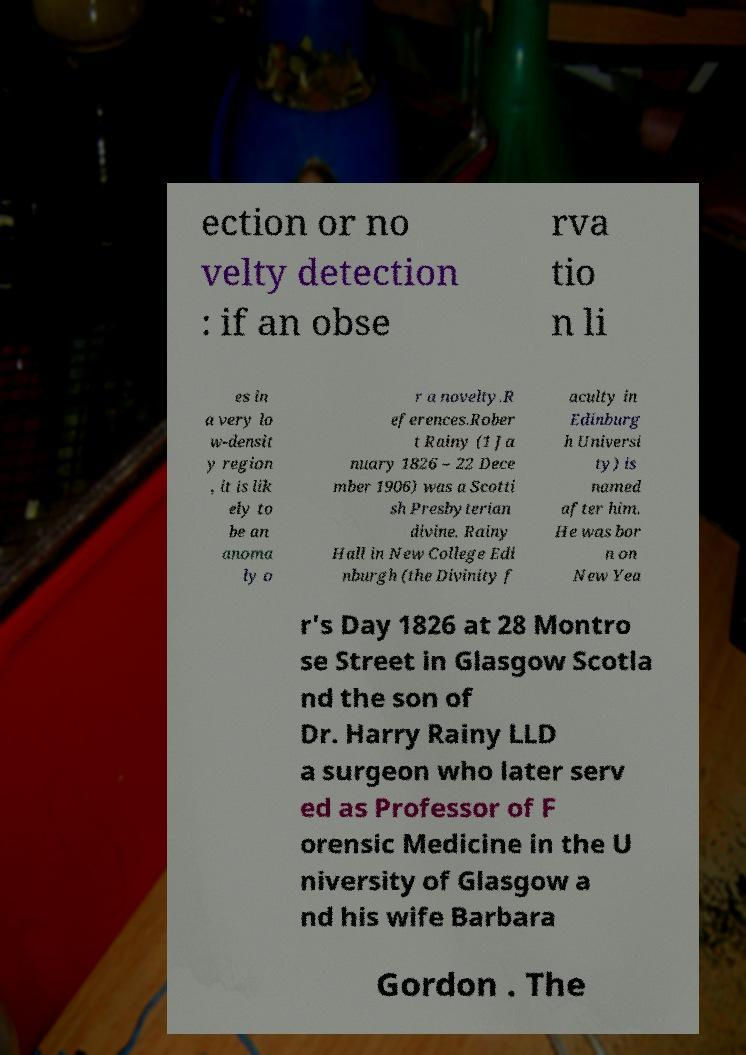Can you accurately transcribe the text from the provided image for me? ection or no velty detection : if an obse rva tio n li es in a very lo w-densit y region , it is lik ely to be an anoma ly o r a novelty.R eferences.Rober t Rainy (1 Ja nuary 1826 – 22 Dece mber 1906) was a Scotti sh Presbyterian divine. Rainy Hall in New College Edi nburgh (the Divinity f aculty in Edinburg h Universi ty) is named after him. He was bor n on New Yea r's Day 1826 at 28 Montro se Street in Glasgow Scotla nd the son of Dr. Harry Rainy LLD a surgeon who later serv ed as Professor of F orensic Medicine in the U niversity of Glasgow a nd his wife Barbara Gordon . The 